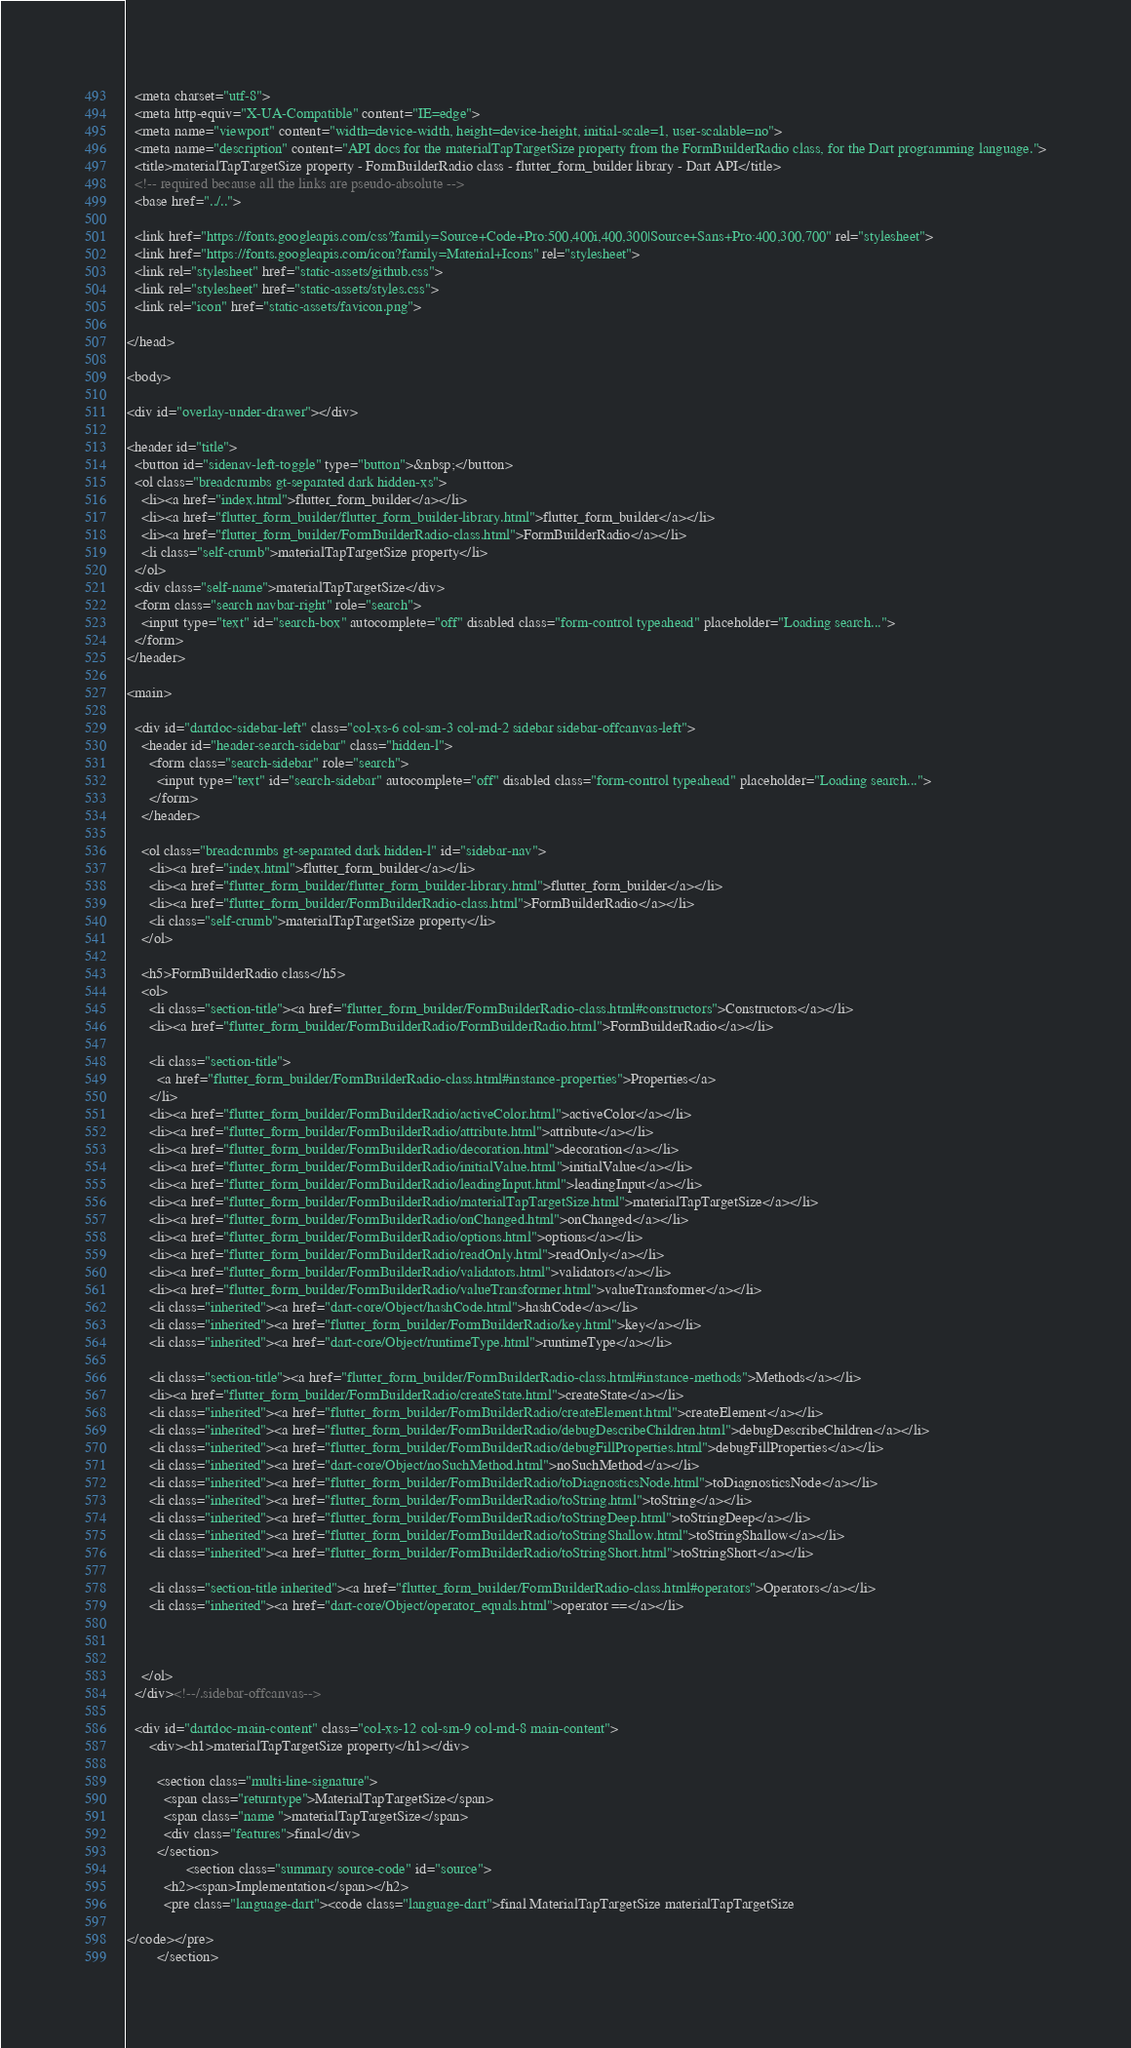<code> <loc_0><loc_0><loc_500><loc_500><_HTML_>  <meta charset="utf-8">
  <meta http-equiv="X-UA-Compatible" content="IE=edge">
  <meta name="viewport" content="width=device-width, height=device-height, initial-scale=1, user-scalable=no">
  <meta name="description" content="API docs for the materialTapTargetSize property from the FormBuilderRadio class, for the Dart programming language.">
  <title>materialTapTargetSize property - FormBuilderRadio class - flutter_form_builder library - Dart API</title>
  <!-- required because all the links are pseudo-absolute -->
  <base href="../..">

  <link href="https://fonts.googleapis.com/css?family=Source+Code+Pro:500,400i,400,300|Source+Sans+Pro:400,300,700" rel="stylesheet">
  <link href="https://fonts.googleapis.com/icon?family=Material+Icons" rel="stylesheet">
  <link rel="stylesheet" href="static-assets/github.css">
  <link rel="stylesheet" href="static-assets/styles.css">
  <link rel="icon" href="static-assets/favicon.png">
  
</head>

<body>

<div id="overlay-under-drawer"></div>

<header id="title">
  <button id="sidenav-left-toggle" type="button">&nbsp;</button>
  <ol class="breadcrumbs gt-separated dark hidden-xs">
    <li><a href="index.html">flutter_form_builder</a></li>
    <li><a href="flutter_form_builder/flutter_form_builder-library.html">flutter_form_builder</a></li>
    <li><a href="flutter_form_builder/FormBuilderRadio-class.html">FormBuilderRadio</a></li>
    <li class="self-crumb">materialTapTargetSize property</li>
  </ol>
  <div class="self-name">materialTapTargetSize</div>
  <form class="search navbar-right" role="search">
    <input type="text" id="search-box" autocomplete="off" disabled class="form-control typeahead" placeholder="Loading search...">
  </form>
</header>

<main>

  <div id="dartdoc-sidebar-left" class="col-xs-6 col-sm-3 col-md-2 sidebar sidebar-offcanvas-left">
    <header id="header-search-sidebar" class="hidden-l">
      <form class="search-sidebar" role="search">
        <input type="text" id="search-sidebar" autocomplete="off" disabled class="form-control typeahead" placeholder="Loading search...">
      </form>
    </header>
    
    <ol class="breadcrumbs gt-separated dark hidden-l" id="sidebar-nav">
      <li><a href="index.html">flutter_form_builder</a></li>
      <li><a href="flutter_form_builder/flutter_form_builder-library.html">flutter_form_builder</a></li>
      <li><a href="flutter_form_builder/FormBuilderRadio-class.html">FormBuilderRadio</a></li>
      <li class="self-crumb">materialTapTargetSize property</li>
    </ol>
    
    <h5>FormBuilderRadio class</h5>
    <ol>
      <li class="section-title"><a href="flutter_form_builder/FormBuilderRadio-class.html#constructors">Constructors</a></li>
      <li><a href="flutter_form_builder/FormBuilderRadio/FormBuilderRadio.html">FormBuilderRadio</a></li>
    
      <li class="section-title">
        <a href="flutter_form_builder/FormBuilderRadio-class.html#instance-properties">Properties</a>
      </li>
      <li><a href="flutter_form_builder/FormBuilderRadio/activeColor.html">activeColor</a></li>
      <li><a href="flutter_form_builder/FormBuilderRadio/attribute.html">attribute</a></li>
      <li><a href="flutter_form_builder/FormBuilderRadio/decoration.html">decoration</a></li>
      <li><a href="flutter_form_builder/FormBuilderRadio/initialValue.html">initialValue</a></li>
      <li><a href="flutter_form_builder/FormBuilderRadio/leadingInput.html">leadingInput</a></li>
      <li><a href="flutter_form_builder/FormBuilderRadio/materialTapTargetSize.html">materialTapTargetSize</a></li>
      <li><a href="flutter_form_builder/FormBuilderRadio/onChanged.html">onChanged</a></li>
      <li><a href="flutter_form_builder/FormBuilderRadio/options.html">options</a></li>
      <li><a href="flutter_form_builder/FormBuilderRadio/readOnly.html">readOnly</a></li>
      <li><a href="flutter_form_builder/FormBuilderRadio/validators.html">validators</a></li>
      <li><a href="flutter_form_builder/FormBuilderRadio/valueTransformer.html">valueTransformer</a></li>
      <li class="inherited"><a href="dart-core/Object/hashCode.html">hashCode</a></li>
      <li class="inherited"><a href="flutter_form_builder/FormBuilderRadio/key.html">key</a></li>
      <li class="inherited"><a href="dart-core/Object/runtimeType.html">runtimeType</a></li>
    
      <li class="section-title"><a href="flutter_form_builder/FormBuilderRadio-class.html#instance-methods">Methods</a></li>
      <li><a href="flutter_form_builder/FormBuilderRadio/createState.html">createState</a></li>
      <li class="inherited"><a href="flutter_form_builder/FormBuilderRadio/createElement.html">createElement</a></li>
      <li class="inherited"><a href="flutter_form_builder/FormBuilderRadio/debugDescribeChildren.html">debugDescribeChildren</a></li>
      <li class="inherited"><a href="flutter_form_builder/FormBuilderRadio/debugFillProperties.html">debugFillProperties</a></li>
      <li class="inherited"><a href="dart-core/Object/noSuchMethod.html">noSuchMethod</a></li>
      <li class="inherited"><a href="flutter_form_builder/FormBuilderRadio/toDiagnosticsNode.html">toDiagnosticsNode</a></li>
      <li class="inherited"><a href="flutter_form_builder/FormBuilderRadio/toString.html">toString</a></li>
      <li class="inherited"><a href="flutter_form_builder/FormBuilderRadio/toStringDeep.html">toStringDeep</a></li>
      <li class="inherited"><a href="flutter_form_builder/FormBuilderRadio/toStringShallow.html">toStringShallow</a></li>
      <li class="inherited"><a href="flutter_form_builder/FormBuilderRadio/toStringShort.html">toStringShort</a></li>
    
      <li class="section-title inherited"><a href="flutter_form_builder/FormBuilderRadio-class.html#operators">Operators</a></li>
      <li class="inherited"><a href="dart-core/Object/operator_equals.html">operator ==</a></li>
    
    
    
    </ol>
  </div><!--/.sidebar-offcanvas-->

  <div id="dartdoc-main-content" class="col-xs-12 col-sm-9 col-md-8 main-content">
      <div><h1>materialTapTargetSize property</h1></div>

        <section class="multi-line-signature">
          <span class="returntype">MaterialTapTargetSize</span>
          <span class="name ">materialTapTargetSize</span>
          <div class="features">final</div>
        </section>
                <section class="summary source-code" id="source">
          <h2><span>Implementation</span></h2>
          <pre class="language-dart"><code class="language-dart">final MaterialTapTargetSize materialTapTargetSize

</code></pre>
        </section>
</code> 